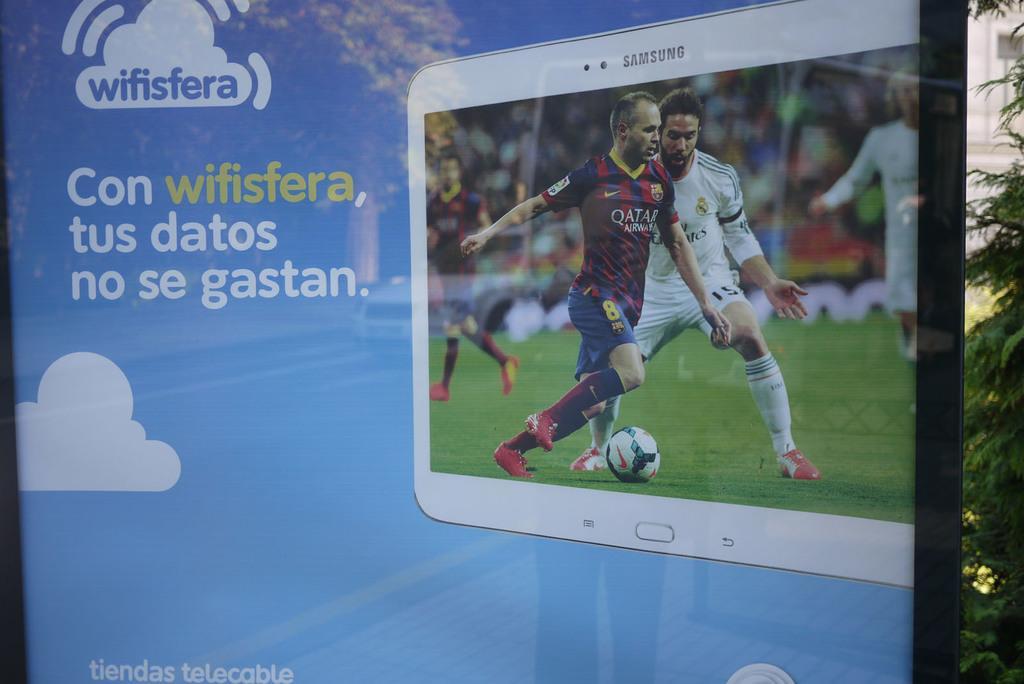Can you describe this image briefly? In this image we can see poster of a Samsung tablet on which football game is displayed and the poster is of blue color, on right side of the image there are some trees. 